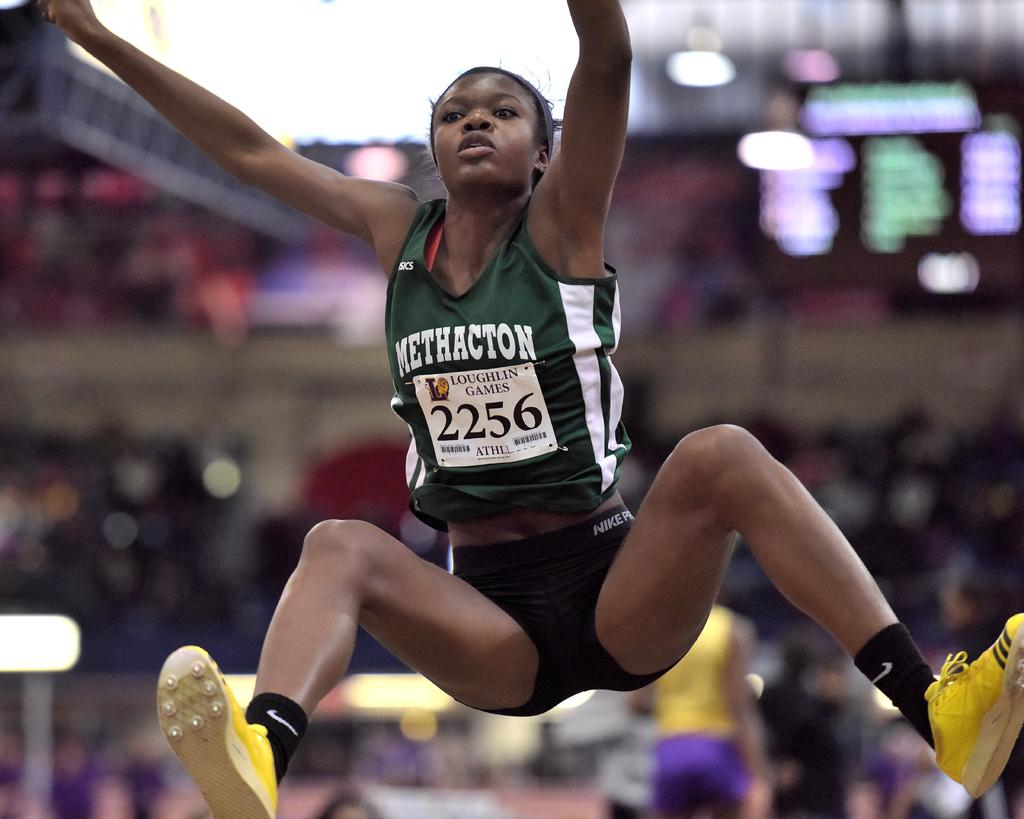Provide a one-sentence caption for the provided image. A female athlete in the Loughlin Games jumps in the air. 